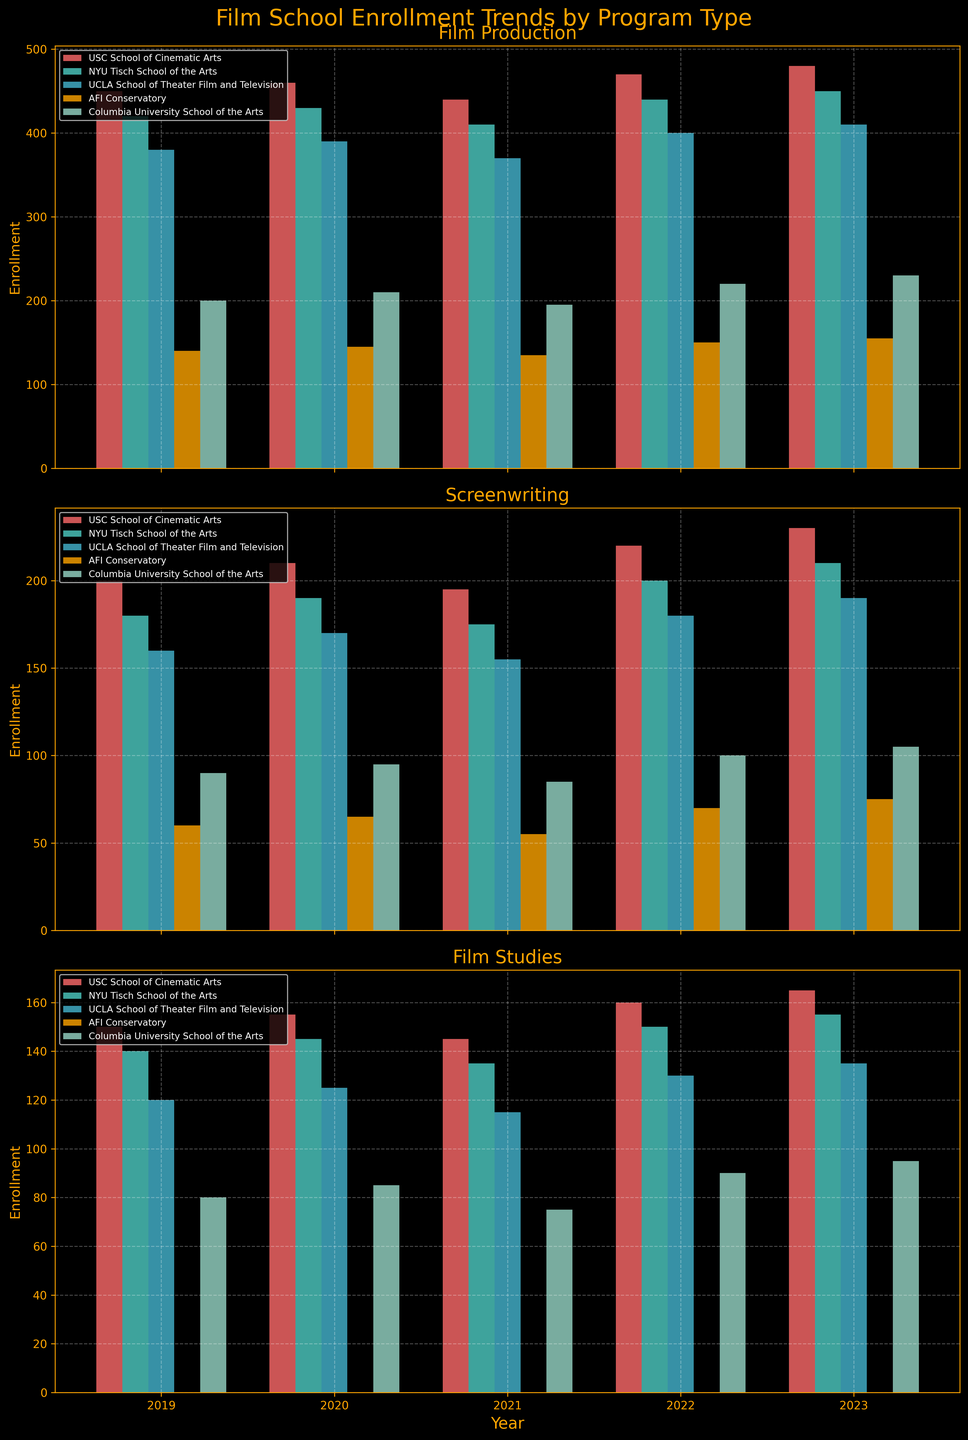Which year saw the highest enrollment in Film Production at USC? Look at the bar heights for USC School of Cinematic Arts in the Film Production subplot. The highest bar corresponds to the year 2023.
Answer: 2023 What is the difference in enrollment for Screenwriting at UCLA between 2019 and 2023? Find the bar heights for Screenwriting at UCLA in both 2019 and 2023, then subtract the 2019 value from the 2023 value (190 - 160 = 30).
Answer: 30 How does the enrollment trend for Film Studies at Columbia University change from 2019 to 2023? Observe the bar heights for Columbia University School of the Arts in the Film Studies subplot from 2019 to 2023. The trend shows an increase year by year (80, 85, 75, 90, 95).
Answer: Increase Which program had the smallest enrollment at AFI Conservatory in any year? Identify the smallest bar in any subplot for AFI Conservatory, which appears in the Screenwriting subplot for 2021 with 55 enrollments.
Answer: Screenwriting in 2021 What is the average enrollment for Screenwriting at NYU Tisch from 2019 to 2023? Add the bars' heights for NYU Tisch in the Screenwriting subplot across all years and divide by the number of years ((180 + 190 + 175 + 200 + 210) / 5 = 191).
Answer: 191 Which Film School consistently had the highest enrollment in Film Production over the last 5 years? Compare the height of bars for USC, NYU, UCLA, AFI, and Columbia in the Film Production subplot across all years. USC consistently has the highest enrollments.
Answer: USC School of Cinematic Arts Did enrollment in Film Studies at NYU Tisch increase, decrease, or remain stable from 2020 to 2021? Look at the heights of bars for NYU Tisch in the Film Studies subplot for 2020 and 2021. The bar height decreases from 145 in 2020 to 135 in 2021.
Answer: Decrease What is the total enrollment for Screenwriting across all schools in the year 2022? Sum up the bar heights in the Screenwriting subplot for the year 2022 (220 + 200 + 180 + 70 + 100 = 770).
Answer: 770 Which program and year combination had the lowest overall enrollment across all schools? Identify the lowest bar height across all subplots and years; Film Studies at any program in the year 2021 shows the lowest at 55.
Answer: Film Studies in 2021 In which years did UCLA have the highest enrollment in Film Production? Look at the bar heights for UCLA in the Film Production subplot. UCLA had the highest enrollment in 2022 and 2023, both at 400 and 410 respectively.
Answer: 2022 and 2023 